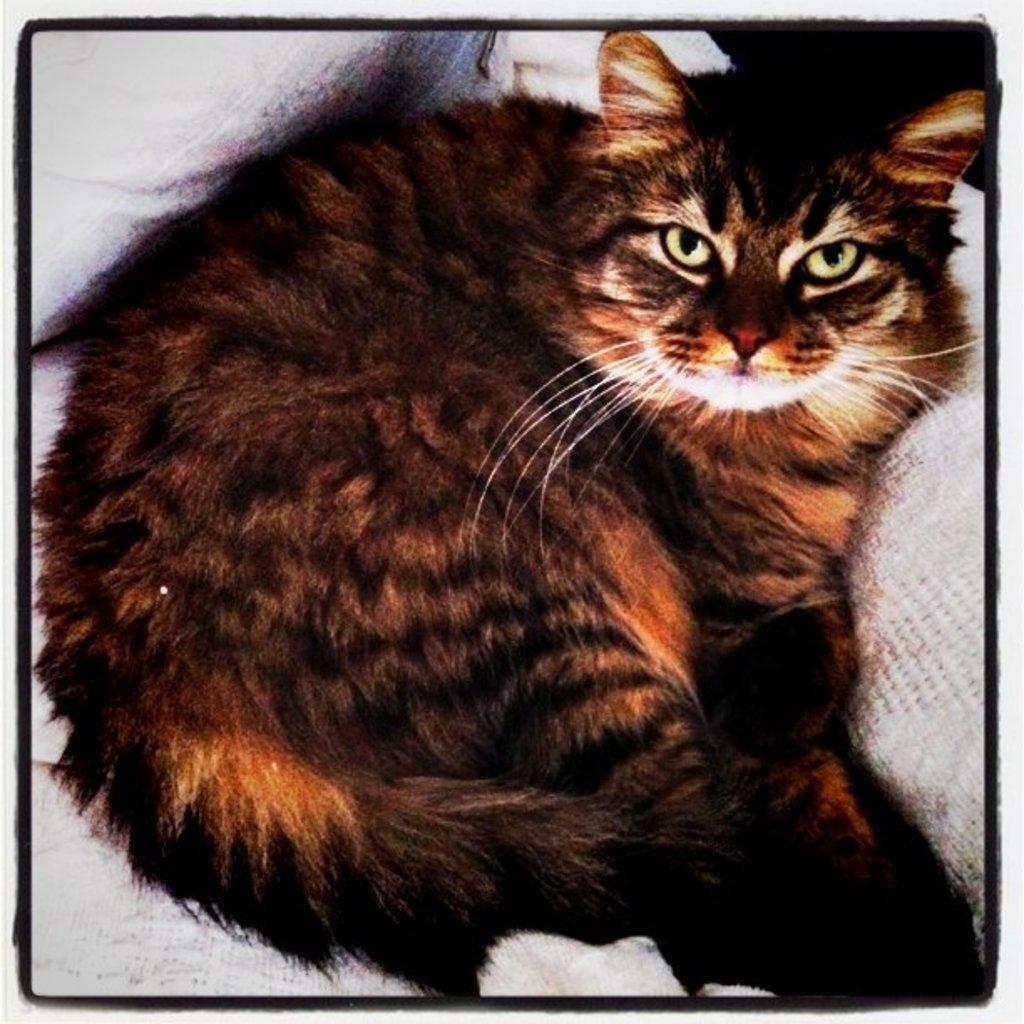Can you describe this image briefly? This is an edited image. We can see a cat lying on an object. 